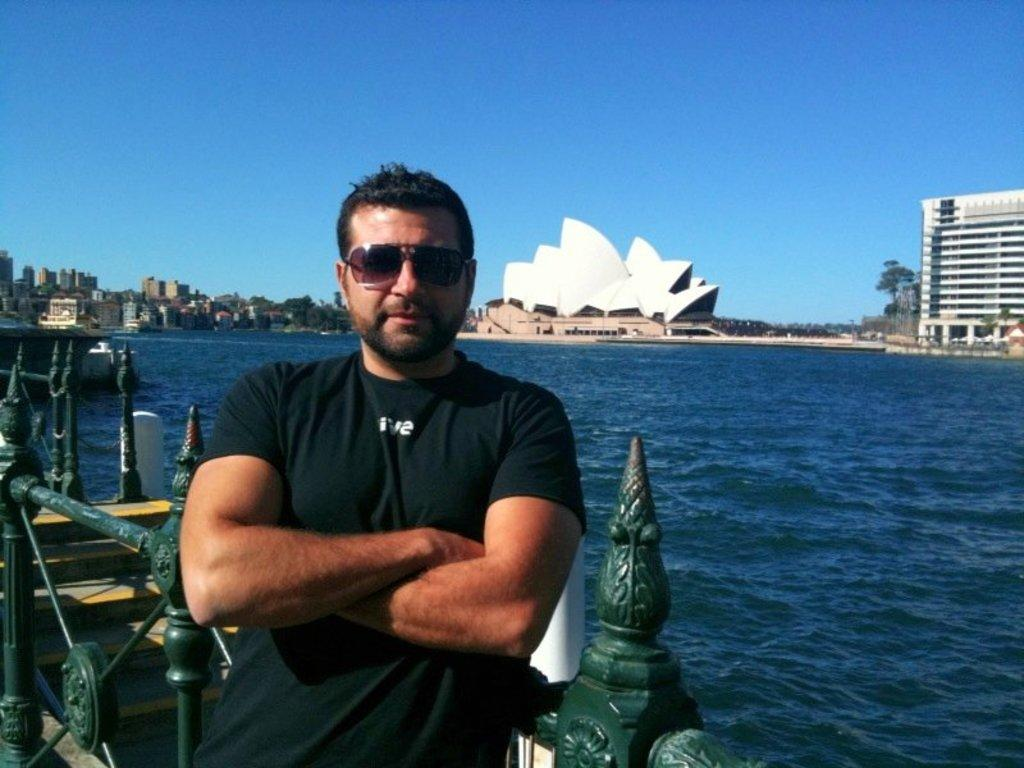What is the man in the foreground of the image doing? The man is standing near the railing in the foreground of the image. What can be seen in the background of the image? Water, buildings, trees, and the sky are visible in the background of the image. How many elements can be seen in the background of the image? There are four elements visible in the background: water, buildings, trees, and the sky. What type of wood is the man using to express his hope in the image? There is no wood present in the image, and the man's emotions or intentions are not explicitly stated. 